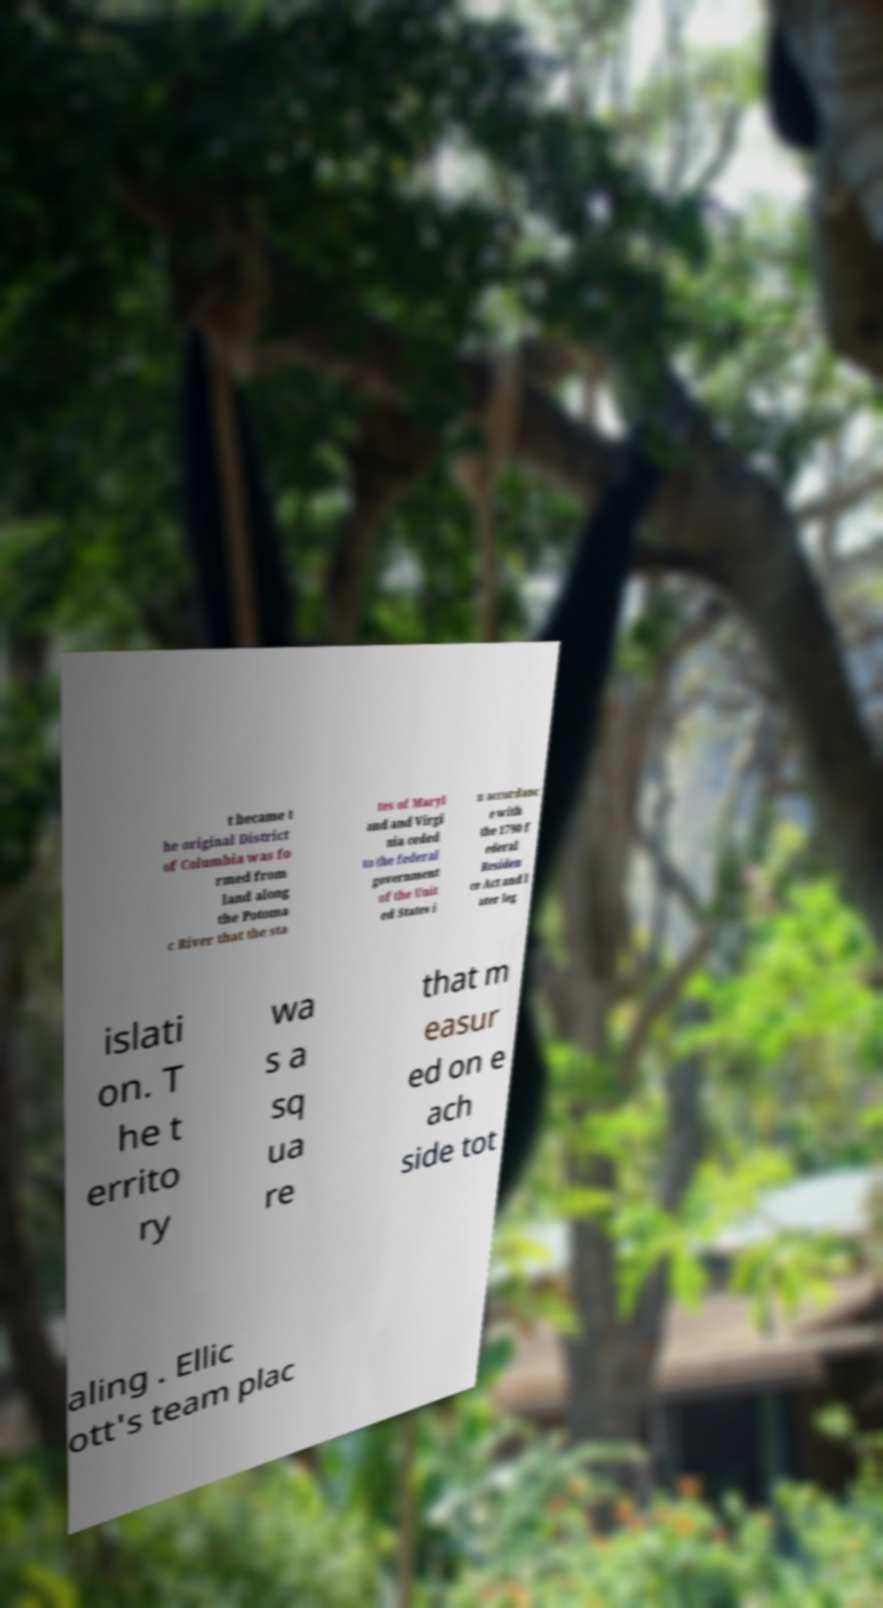What messages or text are displayed in this image? I need them in a readable, typed format. t became t he original District of Columbia was fo rmed from land along the Potoma c River that the sta tes of Maryl and and Virgi nia ceded to the federal government of the Unit ed States i n accordanc e with the 1790 f ederal Residen ce Act and l ater leg islati on. T he t errito ry wa s a sq ua re that m easur ed on e ach side tot aling . Ellic ott's team plac 